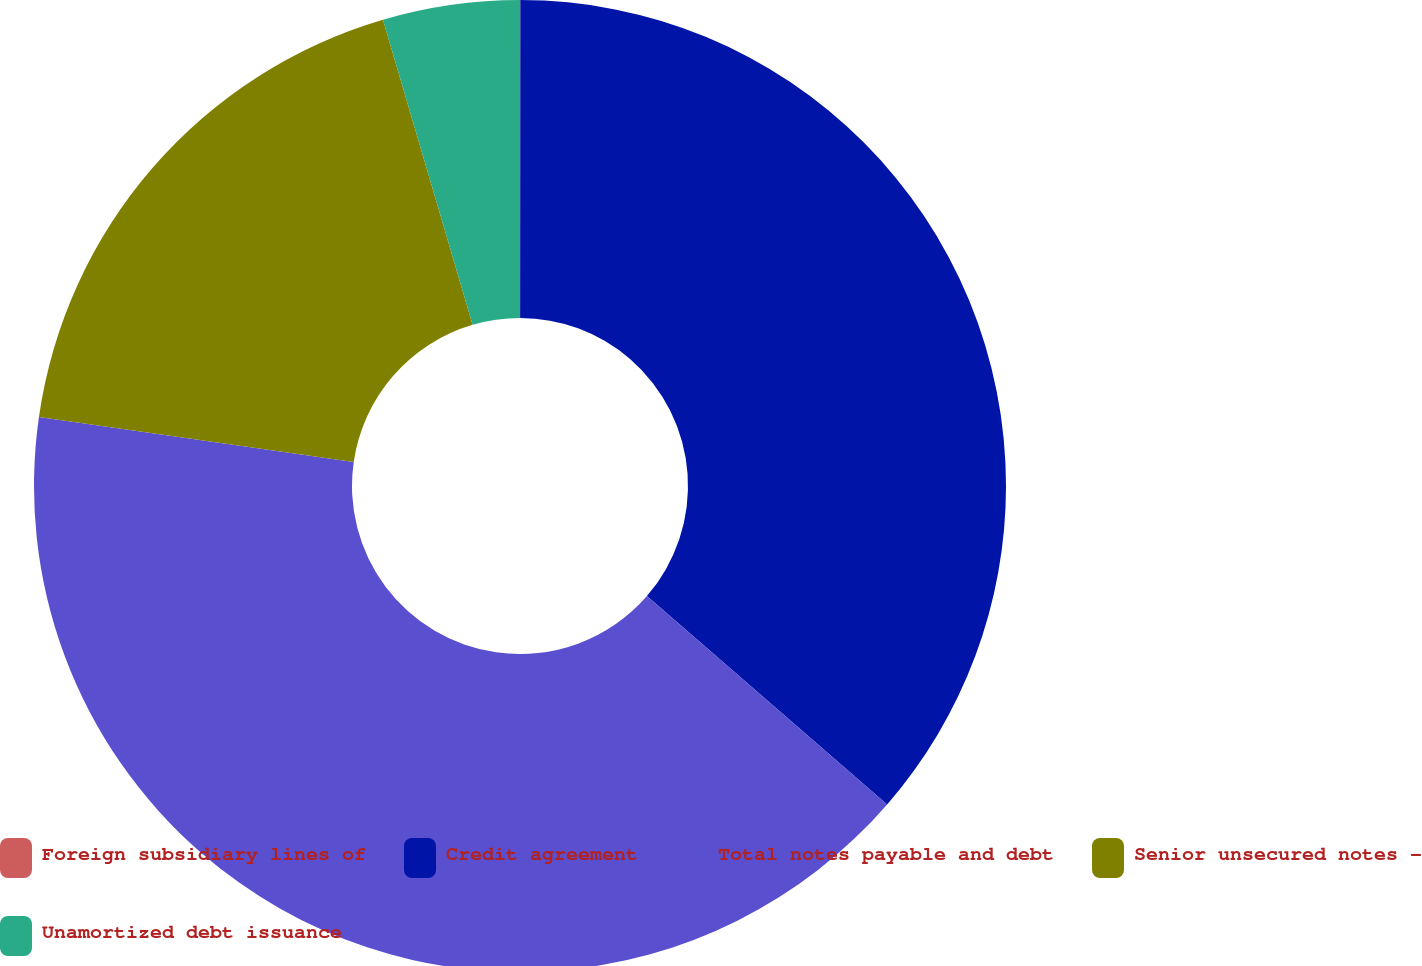Convert chart. <chart><loc_0><loc_0><loc_500><loc_500><pie_chart><fcel>Foreign subsidiary lines of<fcel>Credit agreement<fcel>Total notes payable and debt<fcel>Senior unsecured notes -<fcel>Unamortized debt issuance<nl><fcel>0.01%<fcel>36.36%<fcel>40.9%<fcel>18.18%<fcel>4.55%<nl></chart> 